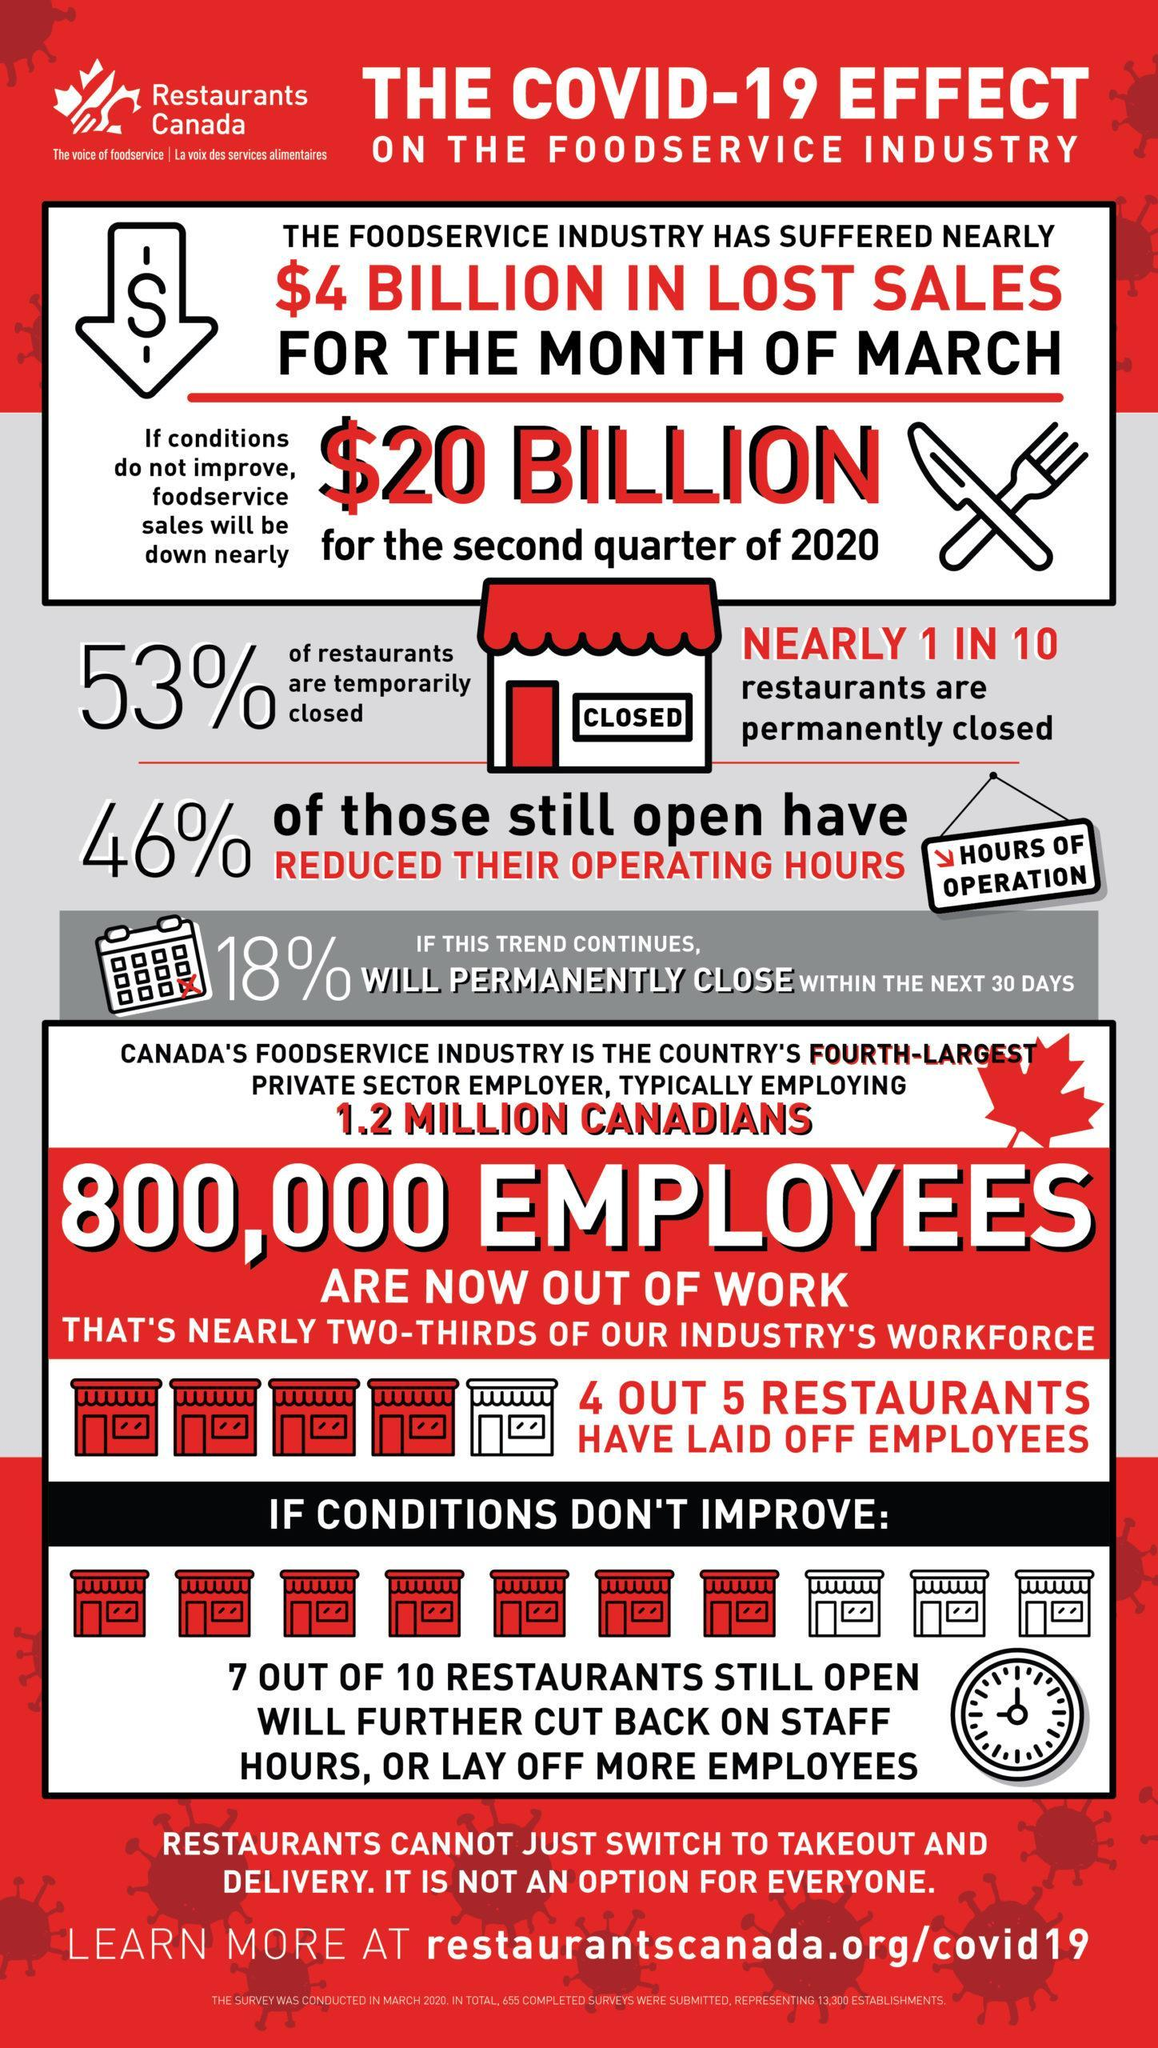What % of restaurants still open will further cut back on staff hours or lay off more employees
Answer the question with a short phrase. 70 What % of restaurants have laid off 80 What is the colour of the door of the restaurant, white or red red What % of restaurants are permanently closed 10 How much reduction is sales is predicted for the second quarter of 2020 $20 billion What is written on the wall of the restaurant closed 